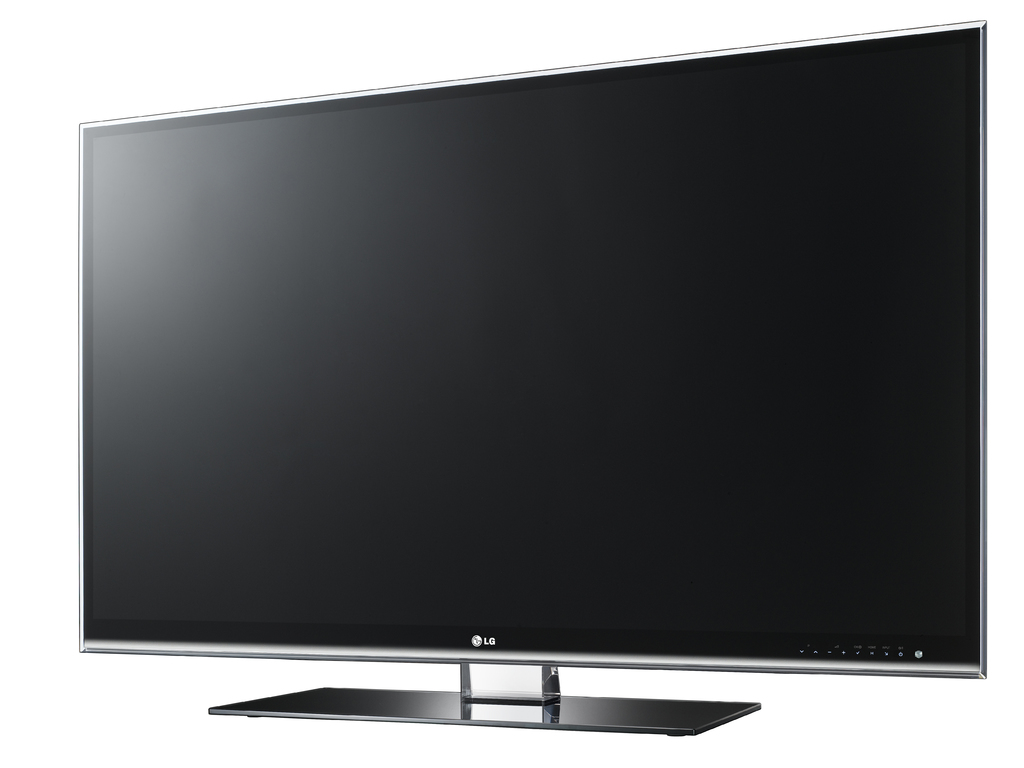Can you tell me some of the key features this LG television might offer? This LG television likely includes features such as 4K resolution, smart connectivity options for streaming platforms, LED backlighting for enhanced contrast, and possibly HDR support for superior picture quality. 